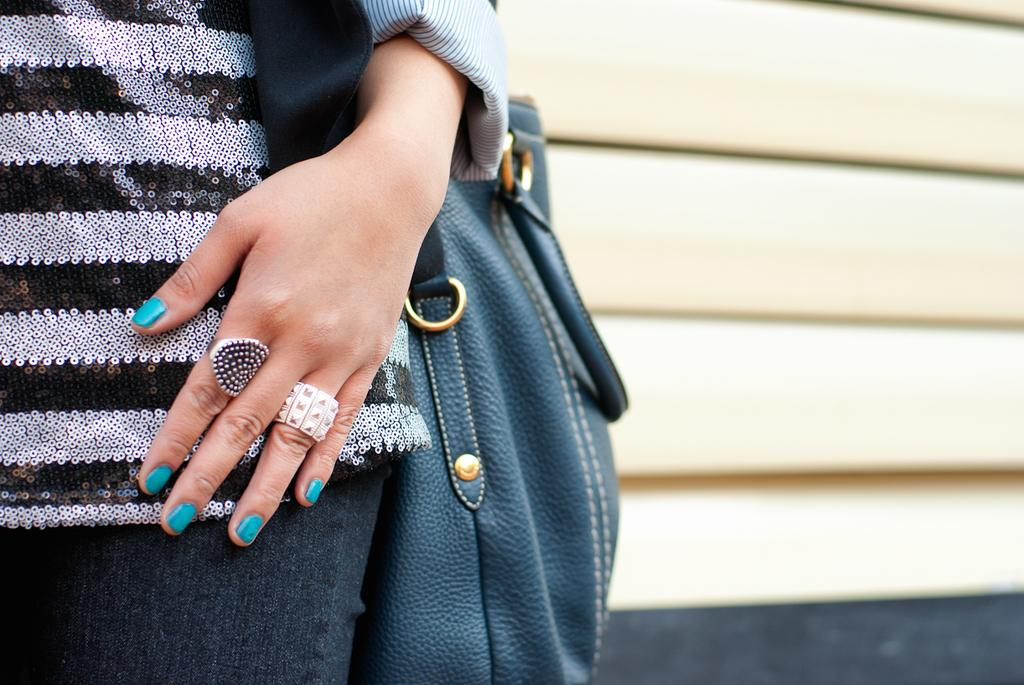Who is the main subject in the image? There is a woman in the image. What is the woman wearing in the image? The woman is wearing a handbag in the image. What detail can be observed about the woman's nails in the image? The woman has green-colored nail paint on her nails in the image. What type of lettuce is the woman holding in the image? There is no lettuce present in the image; the woman is not holding any lettuce. 